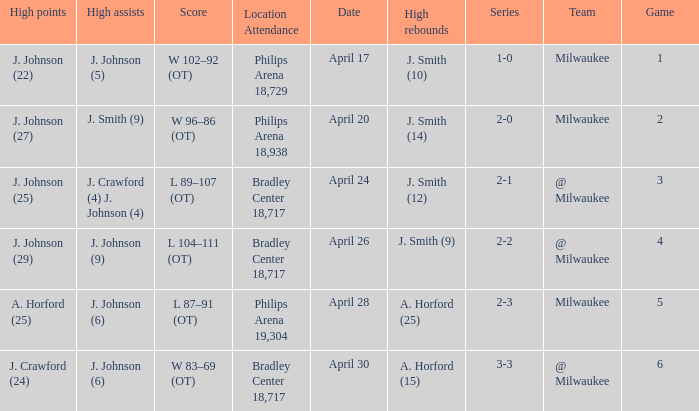What were the amount of rebounds in game 2? J. Smith (14). 